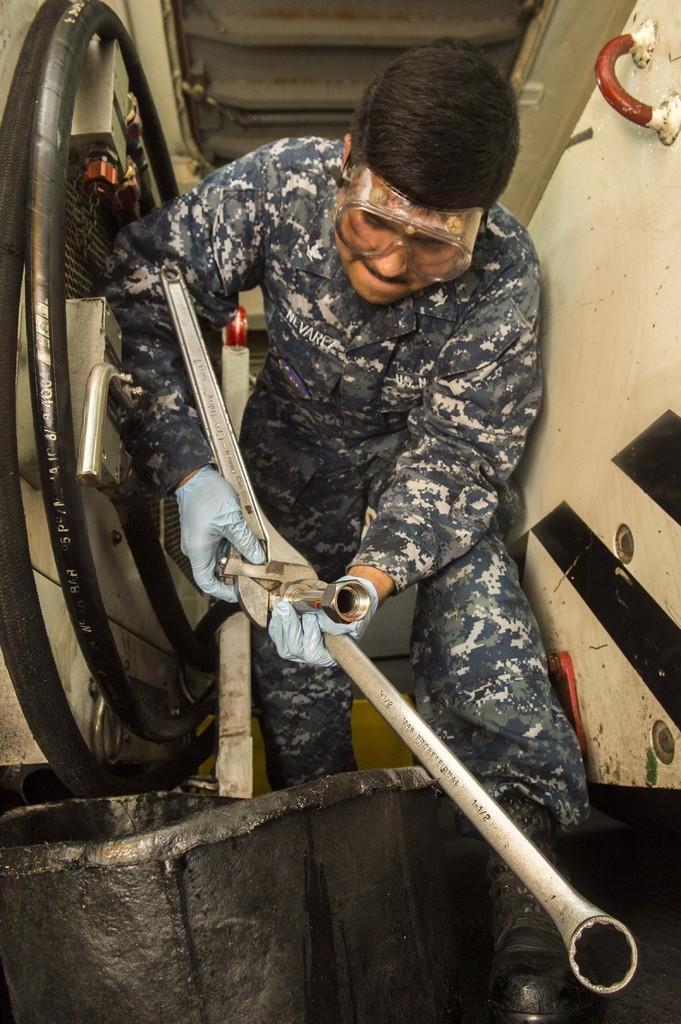Please provide a concise description of this image. In the center of the image there is a person holding some object in his hand. 